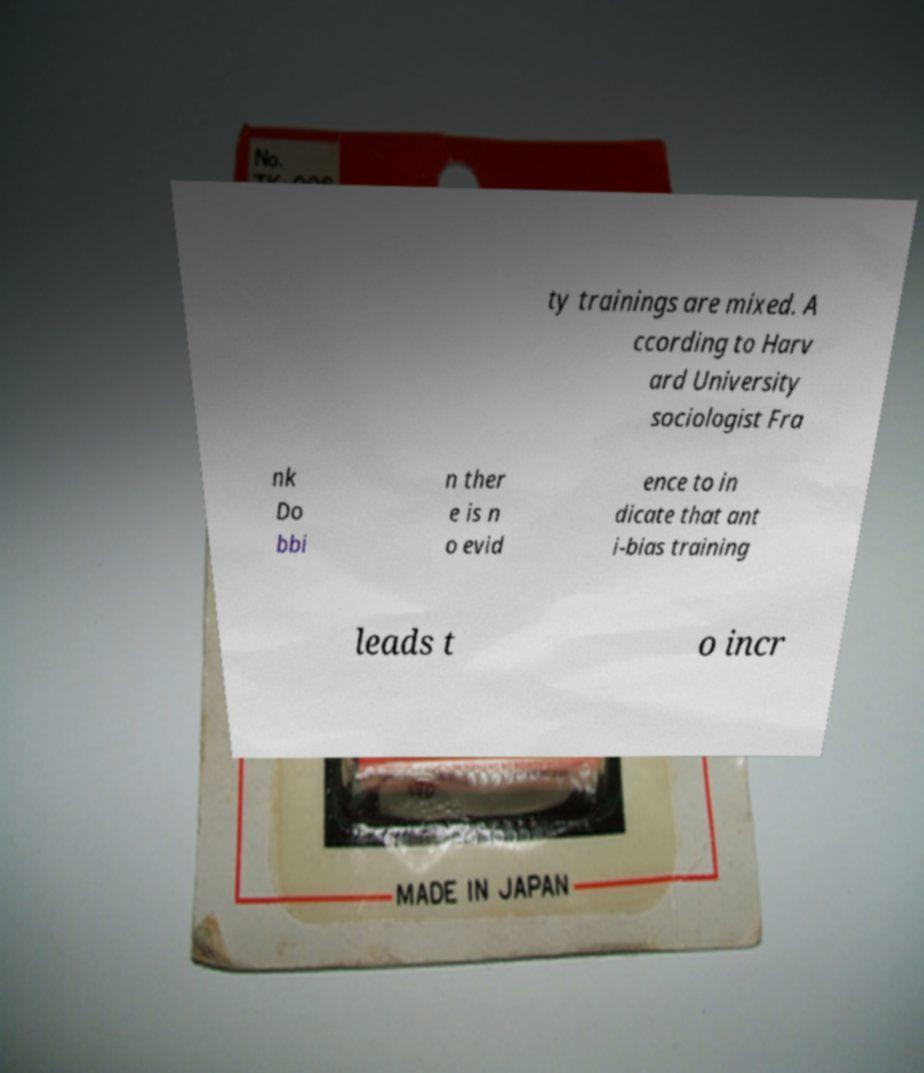Could you extract and type out the text from this image? ty trainings are mixed. A ccording to Harv ard University sociologist Fra nk Do bbi n ther e is n o evid ence to in dicate that ant i-bias training leads t o incr 